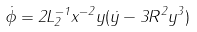Convert formula to latex. <formula><loc_0><loc_0><loc_500><loc_500>\dot { \phi } = 2 L _ { 2 } ^ { - 1 } x ^ { - 2 } y ( \dot { y } - 3 R ^ { 2 } y ^ { 3 } )</formula> 